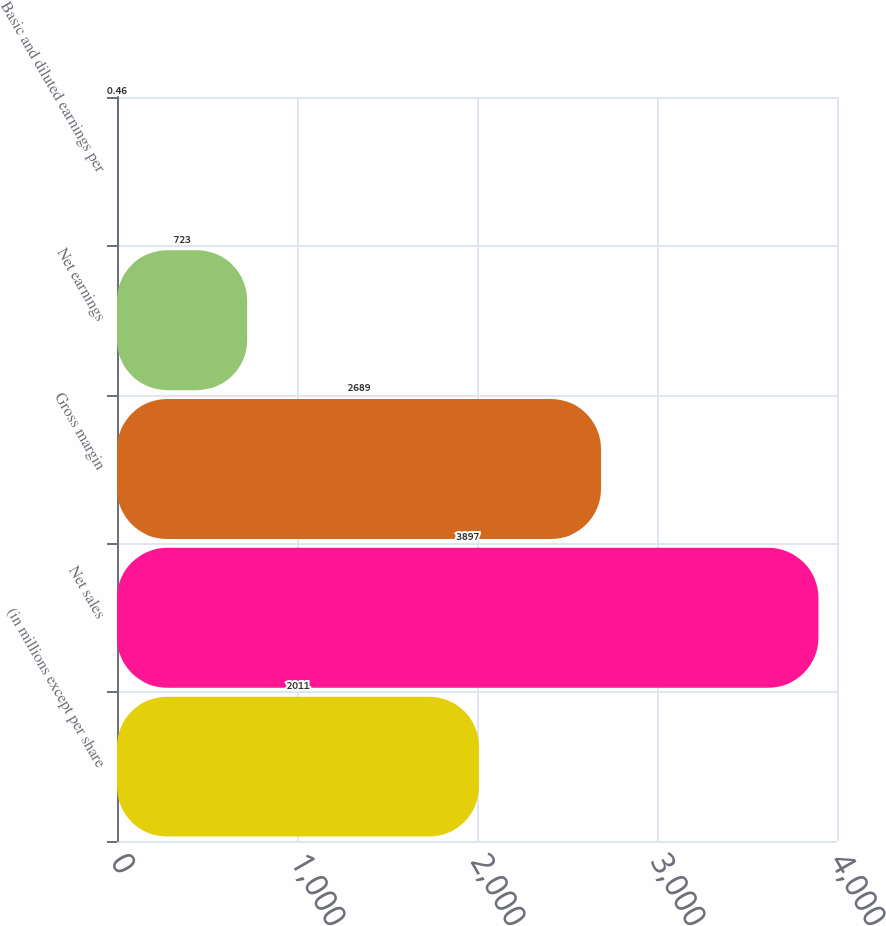Convert chart to OTSL. <chart><loc_0><loc_0><loc_500><loc_500><bar_chart><fcel>(in millions except per share<fcel>Net sales<fcel>Gross margin<fcel>Net earnings<fcel>Basic and diluted earnings per<nl><fcel>2011<fcel>3897<fcel>2689<fcel>723<fcel>0.46<nl></chart> 